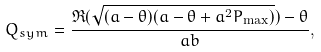<formula> <loc_0><loc_0><loc_500><loc_500>Q _ { s y m } = \frac { \Re ( \sqrt { ( a - \theta ) ( a - \theta + a ^ { 2 } P _ { \max } ) } ) - \theta } { a b } ,</formula> 